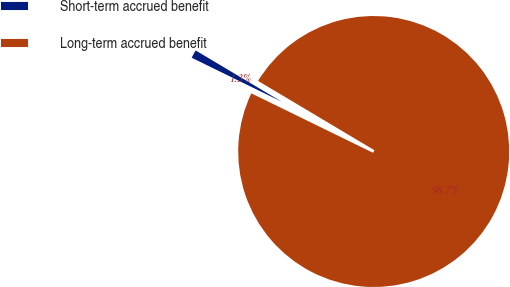Convert chart to OTSL. <chart><loc_0><loc_0><loc_500><loc_500><pie_chart><fcel>Short-term accrued benefit<fcel>Long-term accrued benefit<nl><fcel>1.32%<fcel>98.68%<nl></chart> 